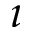<formula> <loc_0><loc_0><loc_500><loc_500>\imath</formula> 